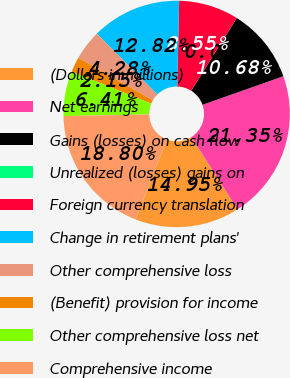<chart> <loc_0><loc_0><loc_500><loc_500><pie_chart><fcel>(Dollars in millions)<fcel>Net earnings<fcel>Gains (losses) on cash flow<fcel>Unrealized (losses) gains on<fcel>Foreign currency translation<fcel>Change in retirement plans'<fcel>Other comprehensive loss<fcel>(Benefit) provision for income<fcel>Other comprehensive loss net<fcel>Comprehensive income<nl><fcel>14.95%<fcel>21.35%<fcel>10.68%<fcel>0.01%<fcel>8.55%<fcel>12.82%<fcel>4.28%<fcel>2.15%<fcel>6.41%<fcel>18.8%<nl></chart> 